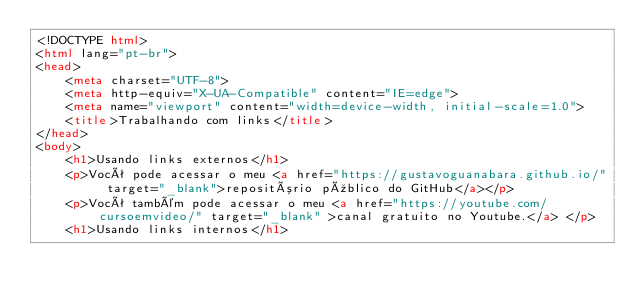<code> <loc_0><loc_0><loc_500><loc_500><_HTML_><!DOCTYPE html>
<html lang="pt-br">
<head>
    <meta charset="UTF-8">
    <meta http-equiv="X-UA-Compatible" content="IE=edge">
    <meta name="viewport" content="width=device-width, initial-scale=1.0">
    <title>Trabalhando com links</title>
</head>
<body>
    <h1>Usando links externos</h1>
    <p>Você pode acessar o meu <a href="https://gustavoguanabara.github.io/" target="_blank">repositório público do GitHub</a></p>
    <p>Você também pode acessar o meu <a href="https://youtube.com/cursoemvideo/" target="_blank" >canal gratuito no Youtube.</a> </p>
    <h1>Usando links internos</h1></code> 